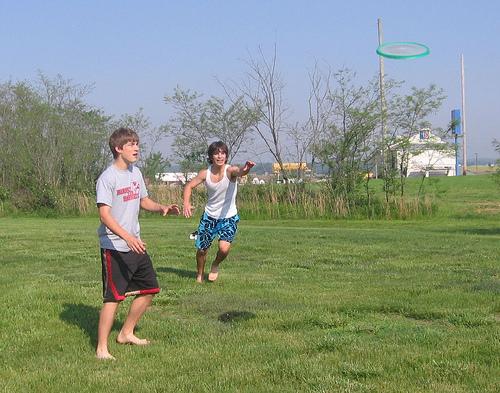How many trees can be seen?
Concise answer only. 4. Is the day cool?
Short answer required. No. Why is the boy's hand in the air?
Keep it brief. Catch frisbee. Any arms raised?
Short answer required. Yes. What brand is on the boy's shirt?
Answer briefly. Not sure. Are they wearing shoes?
Keep it brief. No. Which game are they playing?
Answer briefly. Frisbee. Are all of these people kids?
Quick response, please. Yes. Are those girls?
Answer briefly. No. How many people are in the picture?
Write a very short answer. 2. Are these teenagers?
Give a very brief answer. Yes. What color are his shorts?
Quick response, please. Black. Are these men on a team?
Keep it brief. No. What is on the man's face?
Be succinct. Nothing. Where is the fleebee?
Give a very brief answer. In air. Are both mean wearing hats?
Write a very short answer. No. Are the boys playing soccer?
Short answer required. No. Which person may be barefoot?
Keep it brief. Both. What game is the boy playing?
Short answer required. Frisbee. How many children do you see?
Keep it brief. 2. 